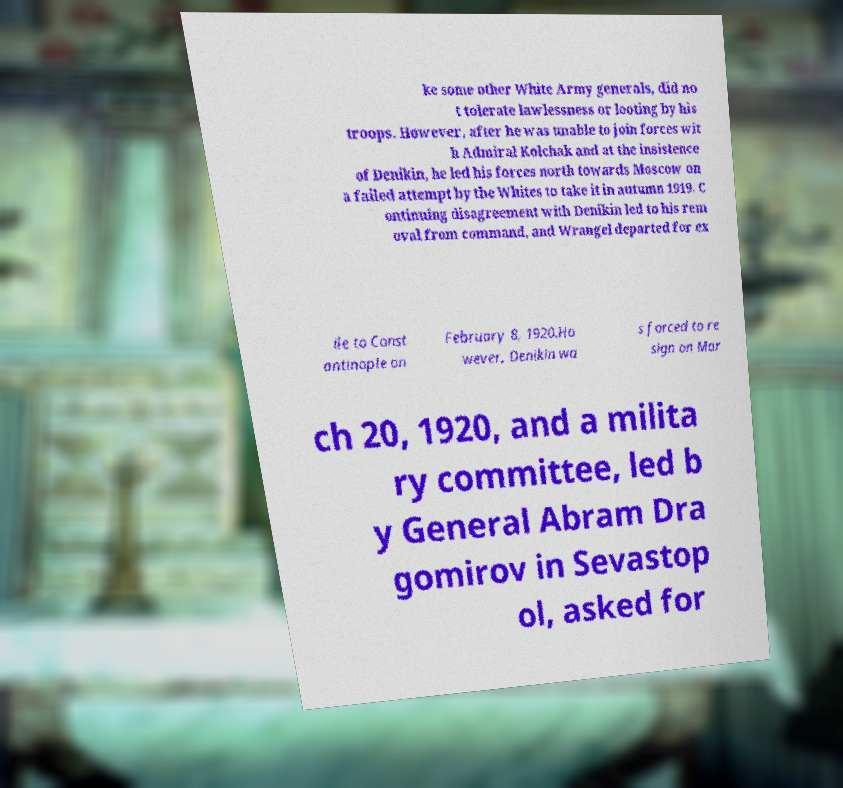What messages or text are displayed in this image? I need them in a readable, typed format. ke some other White Army generals, did no t tolerate lawlessness or looting by his troops. However, after he was unable to join forces wit h Admiral Kolchak and at the insistence of Denikin, he led his forces north towards Moscow on a failed attempt by the Whites to take it in autumn 1919. C ontinuing disagreement with Denikin led to his rem oval from command, and Wrangel departed for ex ile to Const antinople on February 8, 1920.Ho wever, Denikin wa s forced to re sign on Mar ch 20, 1920, and a milita ry committee, led b y General Abram Dra gomirov in Sevastop ol, asked for 